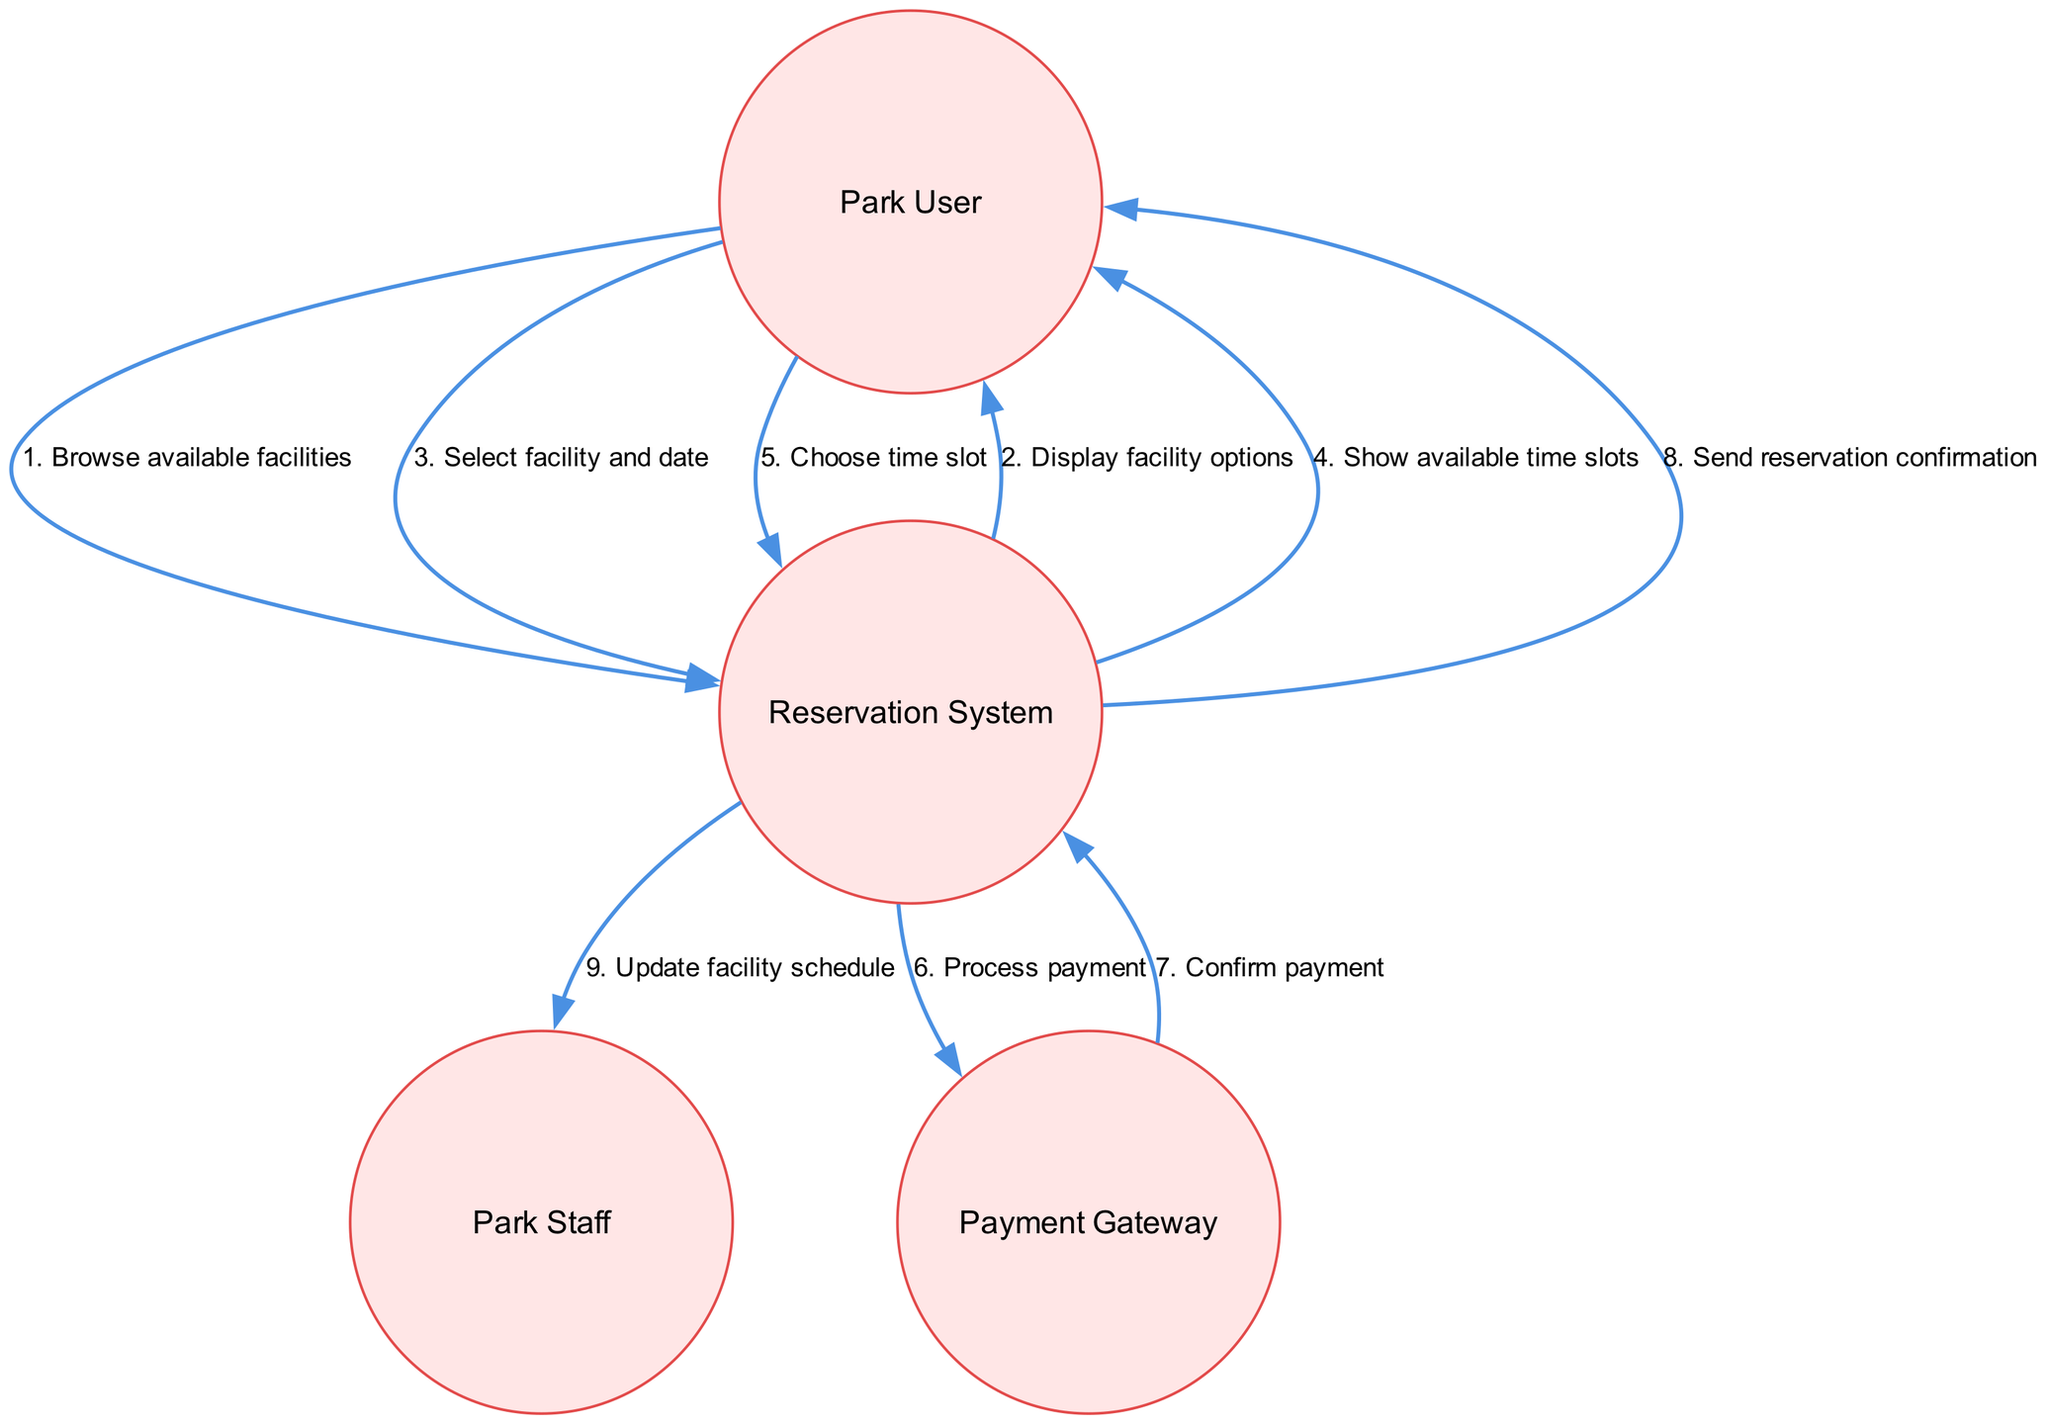What is the first action taken by the Park User? The first action listed in the sequences is "Browse available facilities", which indicates that the Park User initiates the process by looking for facilities to reserve.
Answer: Browse available facilities How many actors are in the diagram? The diagram contains four actors: Park User, Reservation System, Park Staff, and Payment Gateway. This can be counted directly from the 'actors' list.
Answer: Four What action does the Reservation System take after the Park User selects a facility and date? After the Park User selects a facility and date, the Reservation System responds by showing available time slots, as indicated in the sequence flow.
Answer: Show available time slots What role does the Payment Gateway play in this process? The Payment Gateway processes the payment and confirms it back to the Reservation System, acting as the transactional intermediary for payments.
Answer: Process payment Which actor receives the reservation confirmation? The Park User is the actor that receives the reservation confirmation from the Reservation System, as described in the last step of the sequence.
Answer: Park User What is the last action in the sequence? The last action in the sequence is "Update facility schedule," which is sent from the Reservation System to the Park Staff, indicating a notification of the reservation.
Answer: Update facility schedule What happens immediately after the payment is processed? After processing the payment, the Payment Gateway sends a confirmation back to the Reservation System, confirming that the payment was successful.
Answer: Confirm payment Describe the flow from the Park User to the Reservation System after they browse available facilities. After browsing, the Park User receives a display of facility options, selects a facility and date, and then chooses a time slot, creating a continuous flow of interaction with the Reservation System.
Answer: Display facility options, Select facility and date, Choose time slot What is the purpose of the "Send reservation confirmation" action? The purpose of this action is to notify the Park User that their reservation has been successfully processed and confirmed, ensuring they are aware of the reservation status.
Answer: Notify user of reservation status 